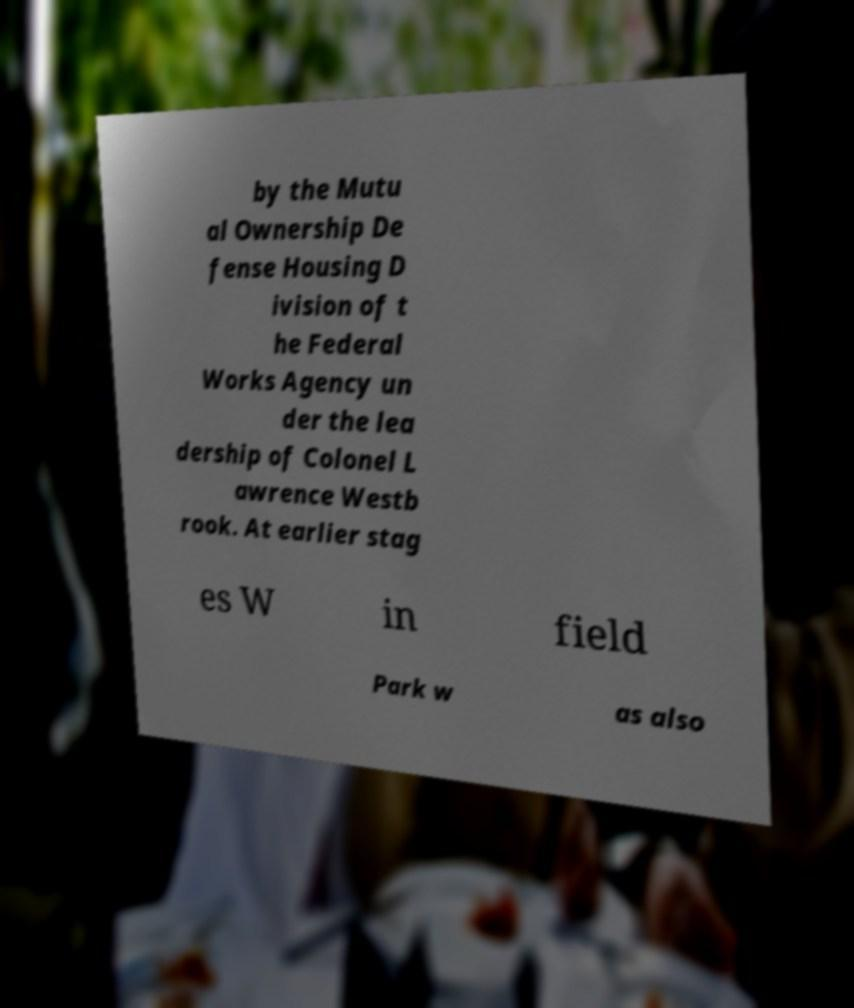What messages or text are displayed in this image? I need them in a readable, typed format. by the Mutu al Ownership De fense Housing D ivision of t he Federal Works Agency un der the lea dership of Colonel L awrence Westb rook. At earlier stag es W in field Park w as also 